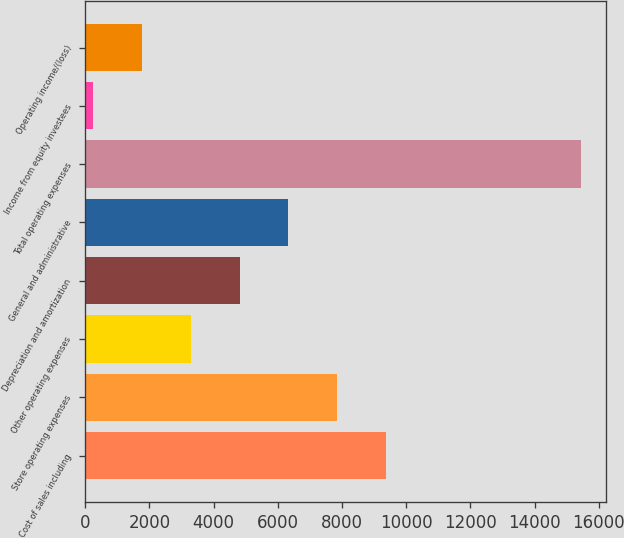Convert chart to OTSL. <chart><loc_0><loc_0><loc_500><loc_500><bar_chart><fcel>Cost of sales including<fcel>Store operating expenses<fcel>Other operating expenses<fcel>Depreciation and amortization<fcel>General and administrative<fcel>Total operating expenses<fcel>Income from equity investees<fcel>Operating income/(loss)<nl><fcel>9366.72<fcel>7847.5<fcel>3289.84<fcel>4809.06<fcel>6328.28<fcel>15443.6<fcel>251.4<fcel>1770.62<nl></chart> 